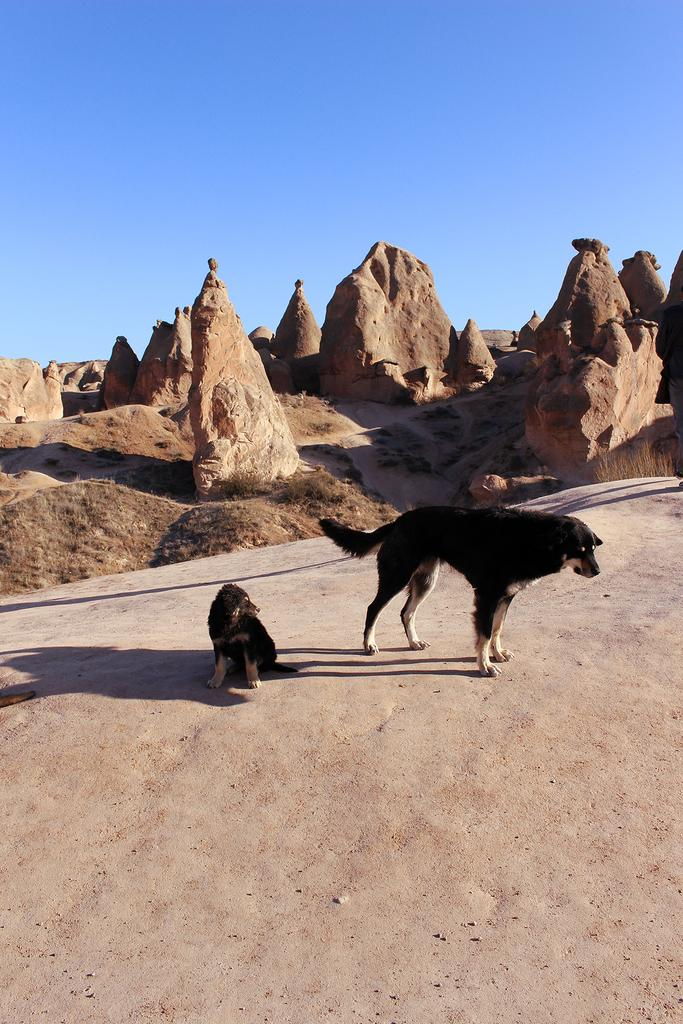How many dogs are present in the image? There are 2 dogs in the image. What is the color of the dogs? The dogs are black in color. What type of surface can be seen in the image? There is ground visible in the image. What is visible in the background of the image? The sky is visible in the background of the image, along with unspecified objects. How many rabbits are sitting on the dogs' heads in the image? There are no rabbits present in the image, and the dogs' heads are not visible. 